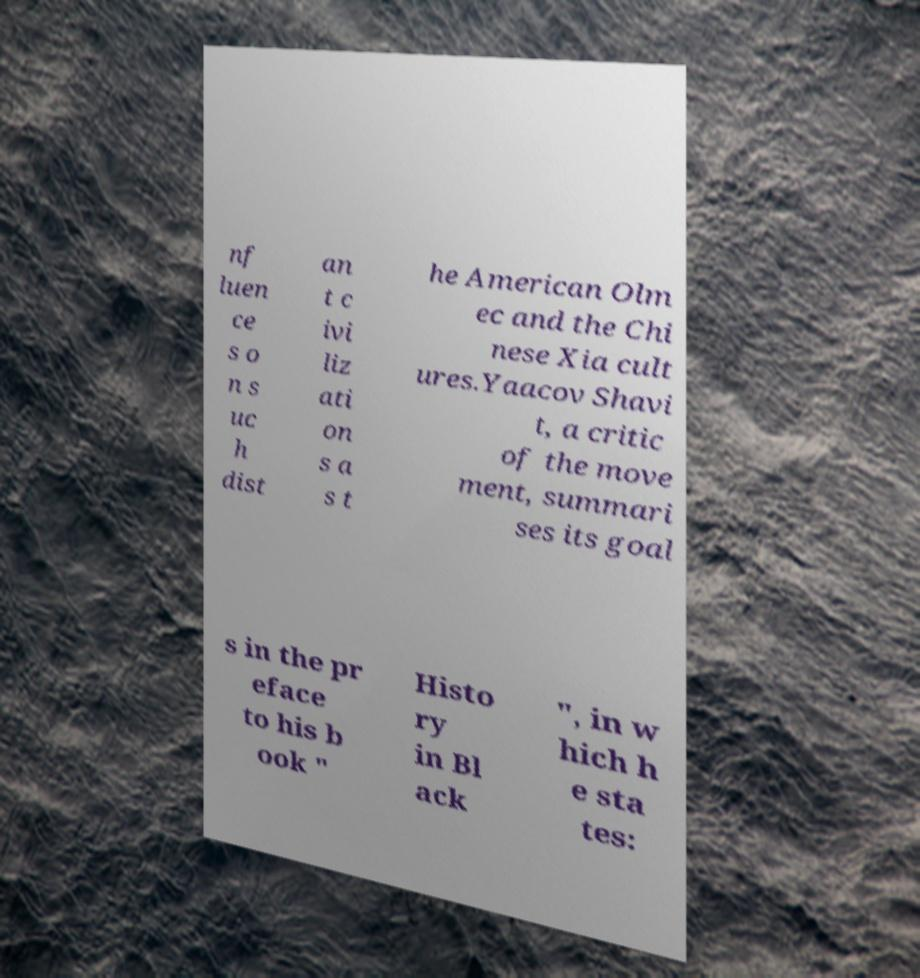Could you extract and type out the text from this image? nf luen ce s o n s uc h dist an t c ivi liz ati on s a s t he American Olm ec and the Chi nese Xia cult ures.Yaacov Shavi t, a critic of the move ment, summari ses its goal s in the pr eface to his b ook " Histo ry in Bl ack ", in w hich h e sta tes: 